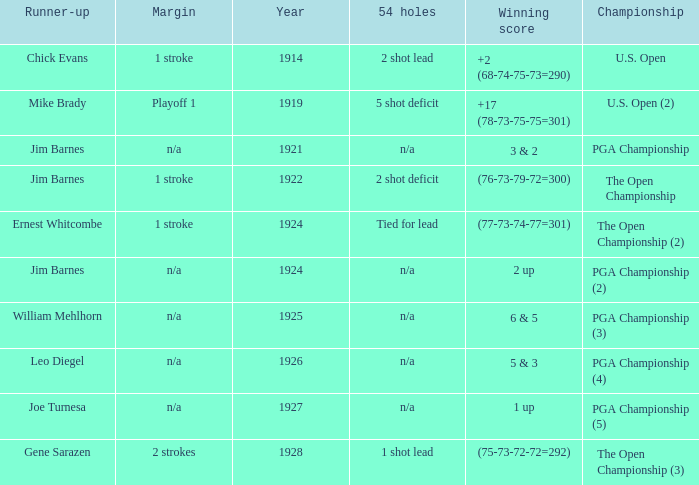WHAT YEAR DID MIKE BRADY GET RUNNER-UP? 1919.0. 